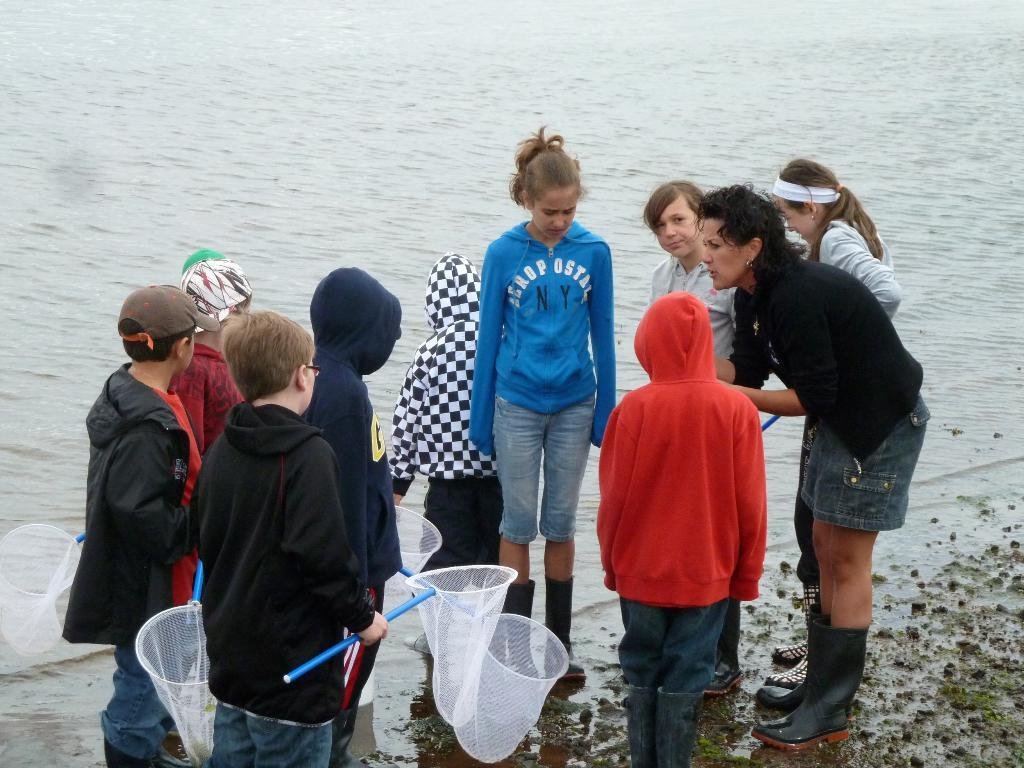How many people are in the image? There are many children in the image. Can you describe the woman in the image? There is a woman in the image. Where are the children and the woman located in the image? The children and the woman are standing near the water. What are the children and the woman holding in their hands? The children and the woman are holding nets in their hands. What can be seen in the background of the image? There is water visible in the background of the image. What type of nut is being used as a toy by the children in the image? There is no nut present in the image; the children are holding nets. 